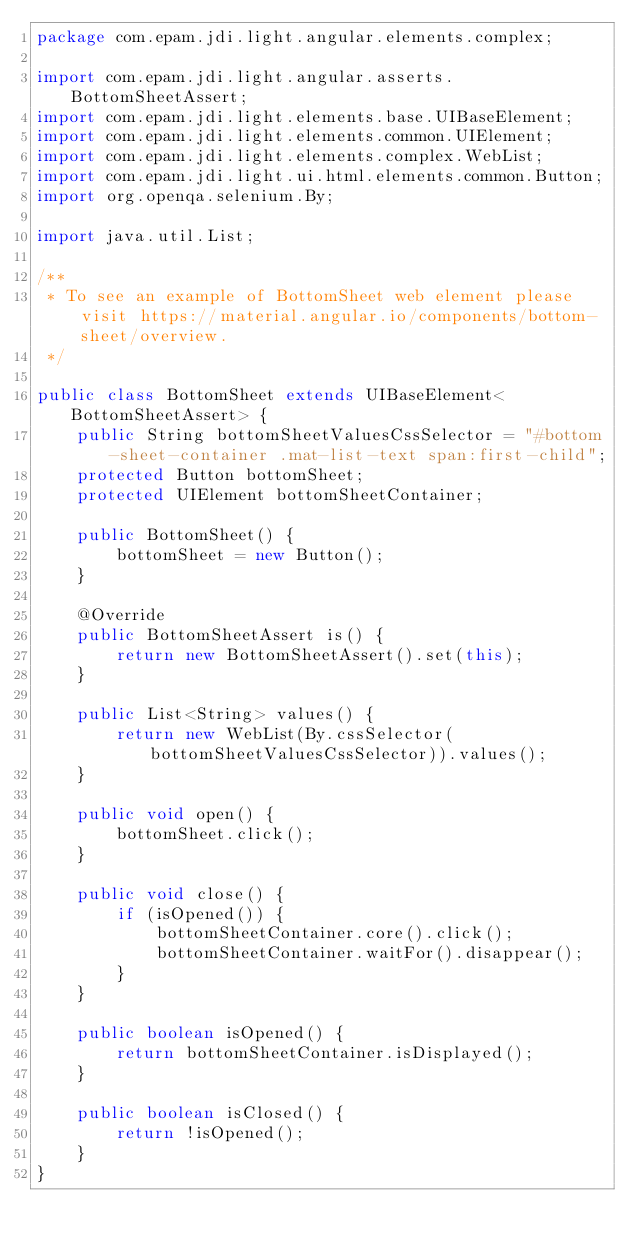<code> <loc_0><loc_0><loc_500><loc_500><_Java_>package com.epam.jdi.light.angular.elements.complex;

import com.epam.jdi.light.angular.asserts.BottomSheetAssert;
import com.epam.jdi.light.elements.base.UIBaseElement;
import com.epam.jdi.light.elements.common.UIElement;
import com.epam.jdi.light.elements.complex.WebList;
import com.epam.jdi.light.ui.html.elements.common.Button;
import org.openqa.selenium.By;

import java.util.List;

/**
 * To see an example of BottomSheet web element please visit https://material.angular.io/components/bottom-sheet/overview.
 */

public class BottomSheet extends UIBaseElement<BottomSheetAssert> {
    public String bottomSheetValuesCssSelector = "#bottom-sheet-container .mat-list-text span:first-child";
    protected Button bottomSheet;
    protected UIElement bottomSheetContainer;
    
    public BottomSheet() {
        bottomSheet = new Button();
    }

    @Override
    public BottomSheetAssert is() {
        return new BottomSheetAssert().set(this);
    }

    public List<String> values() {
        return new WebList(By.cssSelector(bottomSheetValuesCssSelector)).values();
    }

    public void open() {
        bottomSheet.click();
    }

    public void close() {
        if (isOpened()) {
            bottomSheetContainer.core().click();
            bottomSheetContainer.waitFor().disappear();
        }
    }

    public boolean isOpened() {
        return bottomSheetContainer.isDisplayed();
    }

    public boolean isClosed() {
        return !isOpened();
    }
}
</code> 